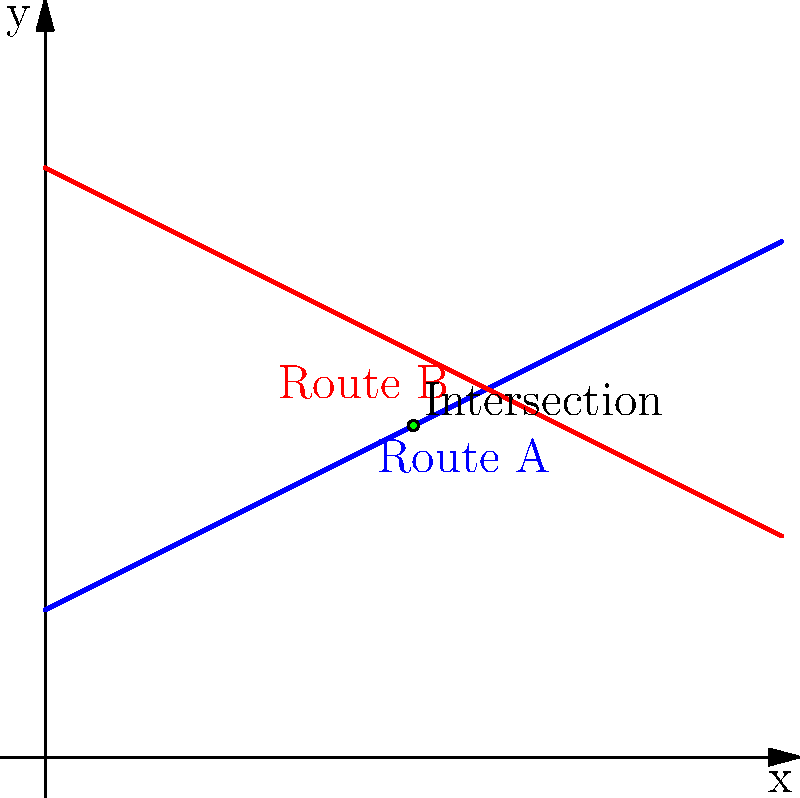At Lake Hubert Depot, two train routes are represented by linear equations on a coordinate system. Route A is given by the equation $y = 0.5x + 2$, and Route B is given by the equation $y = -0.5x + 8$. At what point do these two routes intersect? To find the intersection point of the two routes, we need to solve the system of equations:

1) Route A: $y = 0.5x + 2$
2) Route B: $y = -0.5x + 8$

At the intersection point, the y-coordinates will be equal. So we can set the right sides of the equations equal to each other:

3) $0.5x + 2 = -0.5x + 8$

Now, let's solve for x:

4) $0.5x + 0.5x = 8 - 2$
5) $x = 6$

To find the y-coordinate, we can substitute x = 6 into either of the original equations. Let's use Route A:

6) $y = 0.5(6) + 2 = 3 + 2 = 5$

Therefore, the intersection point is (6, 5).

To verify, we can substitute these coordinates into both original equations:

Route A: $5 = 0.5(6) + 2$ ✓
Route B: $5 = -0.5(6) + 8$ ✓

Both equations are satisfied, confirming our solution.
Answer: (6, 5) 